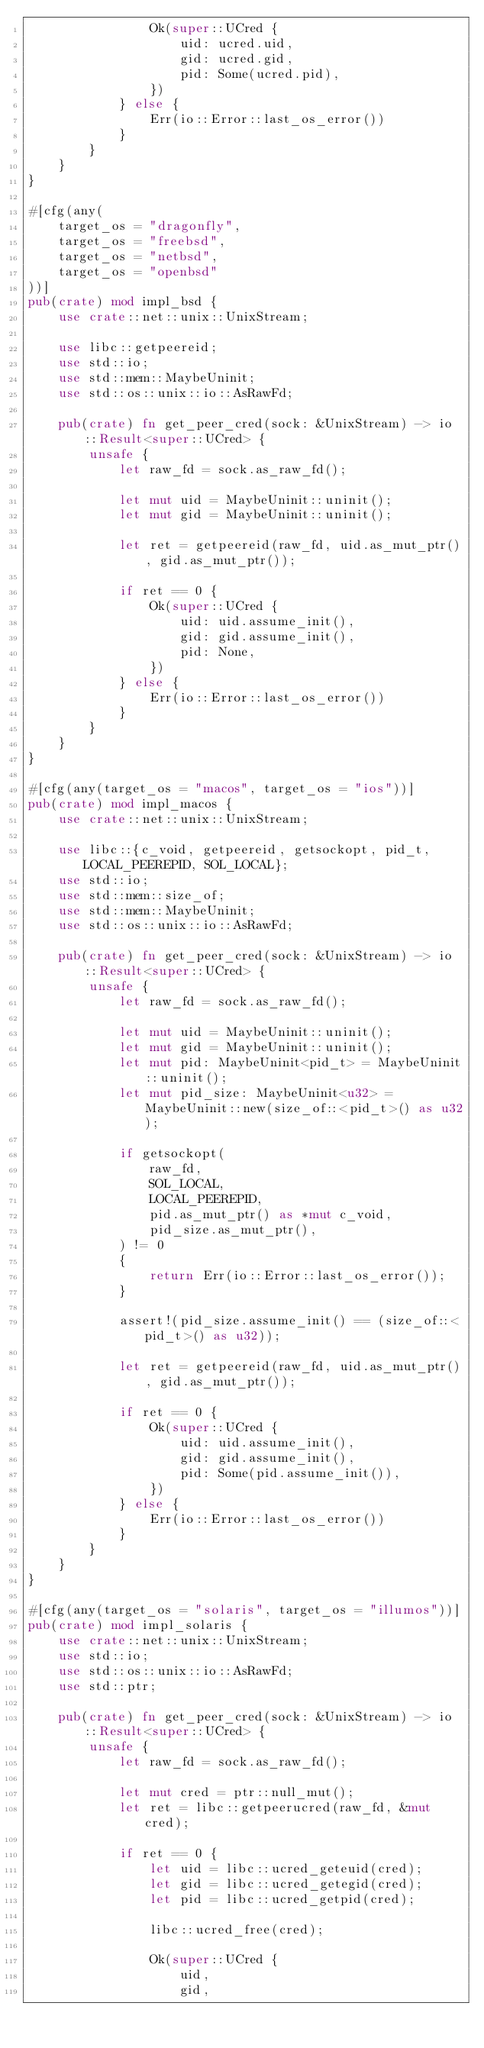Convert code to text. <code><loc_0><loc_0><loc_500><loc_500><_Rust_>                Ok(super::UCred {
                    uid: ucred.uid,
                    gid: ucred.gid,
                    pid: Some(ucred.pid),
                })
            } else {
                Err(io::Error::last_os_error())
            }
        }
    }
}

#[cfg(any(
    target_os = "dragonfly",
    target_os = "freebsd",
    target_os = "netbsd",
    target_os = "openbsd"
))]
pub(crate) mod impl_bsd {
    use crate::net::unix::UnixStream;

    use libc::getpeereid;
    use std::io;
    use std::mem::MaybeUninit;
    use std::os::unix::io::AsRawFd;

    pub(crate) fn get_peer_cred(sock: &UnixStream) -> io::Result<super::UCred> {
        unsafe {
            let raw_fd = sock.as_raw_fd();

            let mut uid = MaybeUninit::uninit();
            let mut gid = MaybeUninit::uninit();

            let ret = getpeereid(raw_fd, uid.as_mut_ptr(), gid.as_mut_ptr());

            if ret == 0 {
                Ok(super::UCred {
                    uid: uid.assume_init(),
                    gid: gid.assume_init(),
                    pid: None,
                })
            } else {
                Err(io::Error::last_os_error())
            }
        }
    }
}

#[cfg(any(target_os = "macos", target_os = "ios"))]
pub(crate) mod impl_macos {
    use crate::net::unix::UnixStream;

    use libc::{c_void, getpeereid, getsockopt, pid_t, LOCAL_PEEREPID, SOL_LOCAL};
    use std::io;
    use std::mem::size_of;
    use std::mem::MaybeUninit;
    use std::os::unix::io::AsRawFd;

    pub(crate) fn get_peer_cred(sock: &UnixStream) -> io::Result<super::UCred> {
        unsafe {
            let raw_fd = sock.as_raw_fd();

            let mut uid = MaybeUninit::uninit();
            let mut gid = MaybeUninit::uninit();
            let mut pid: MaybeUninit<pid_t> = MaybeUninit::uninit();
            let mut pid_size: MaybeUninit<u32> = MaybeUninit::new(size_of::<pid_t>() as u32);

            if getsockopt(
                raw_fd,
                SOL_LOCAL,
                LOCAL_PEEREPID,
                pid.as_mut_ptr() as *mut c_void,
                pid_size.as_mut_ptr(),
            ) != 0
            {
                return Err(io::Error::last_os_error());
            }

            assert!(pid_size.assume_init() == (size_of::<pid_t>() as u32));

            let ret = getpeereid(raw_fd, uid.as_mut_ptr(), gid.as_mut_ptr());

            if ret == 0 {
                Ok(super::UCred {
                    uid: uid.assume_init(),
                    gid: gid.assume_init(),
                    pid: Some(pid.assume_init()),
                })
            } else {
                Err(io::Error::last_os_error())
            }
        }
    }
}

#[cfg(any(target_os = "solaris", target_os = "illumos"))]
pub(crate) mod impl_solaris {
    use crate::net::unix::UnixStream;
    use std::io;
    use std::os::unix::io::AsRawFd;
    use std::ptr;

    pub(crate) fn get_peer_cred(sock: &UnixStream) -> io::Result<super::UCred> {
        unsafe {
            let raw_fd = sock.as_raw_fd();

            let mut cred = ptr::null_mut();
            let ret = libc::getpeerucred(raw_fd, &mut cred);

            if ret == 0 {
                let uid = libc::ucred_geteuid(cred);
                let gid = libc::ucred_getegid(cred);
                let pid = libc::ucred_getpid(cred);

                libc::ucred_free(cred);

                Ok(super::UCred {
                    uid,
                    gid,</code> 